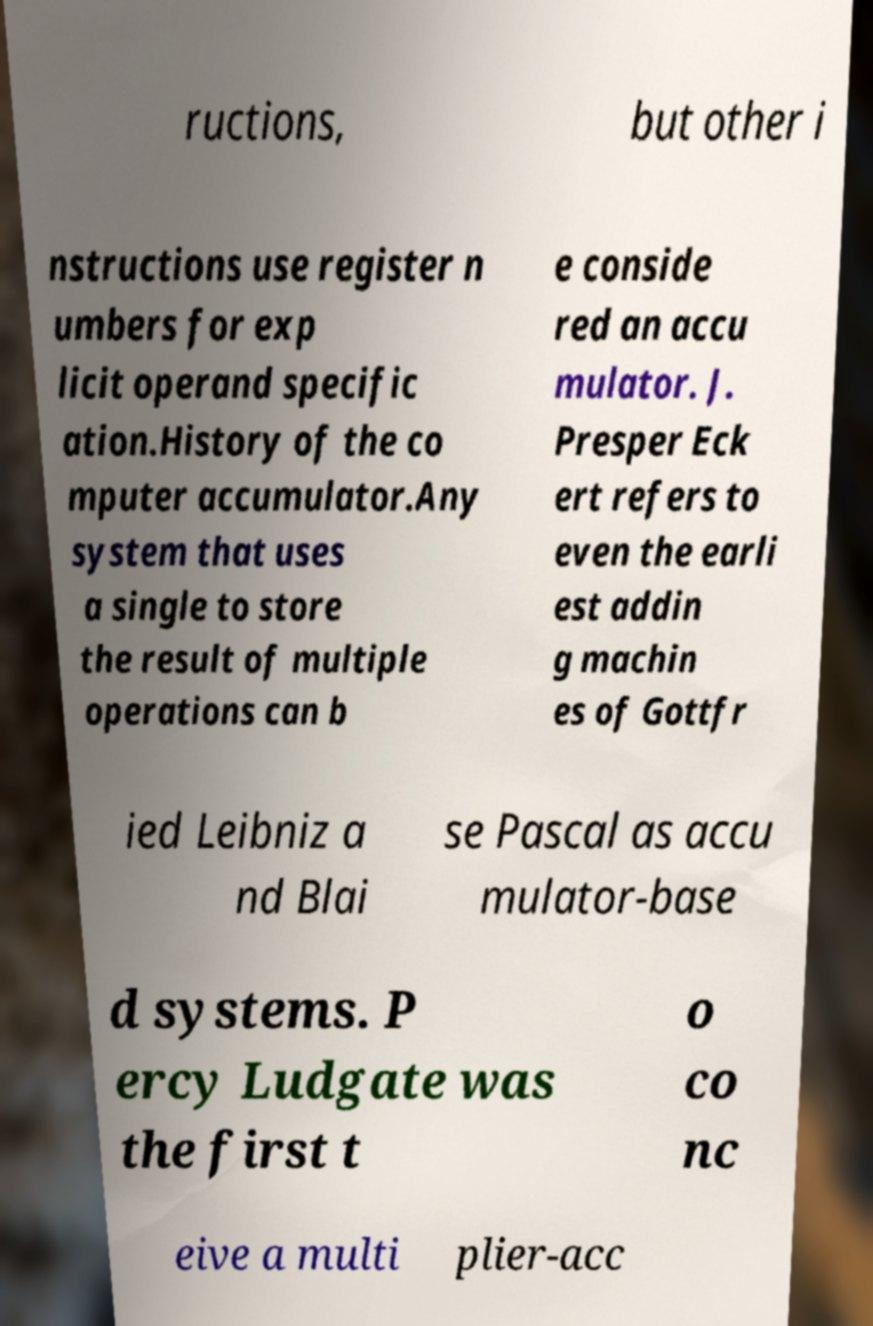Can you read and provide the text displayed in the image?This photo seems to have some interesting text. Can you extract and type it out for me? ructions, but other i nstructions use register n umbers for exp licit operand specific ation.History of the co mputer accumulator.Any system that uses a single to store the result of multiple operations can b e conside red an accu mulator. J. Presper Eck ert refers to even the earli est addin g machin es of Gottfr ied Leibniz a nd Blai se Pascal as accu mulator-base d systems. P ercy Ludgate was the first t o co nc eive a multi plier-acc 